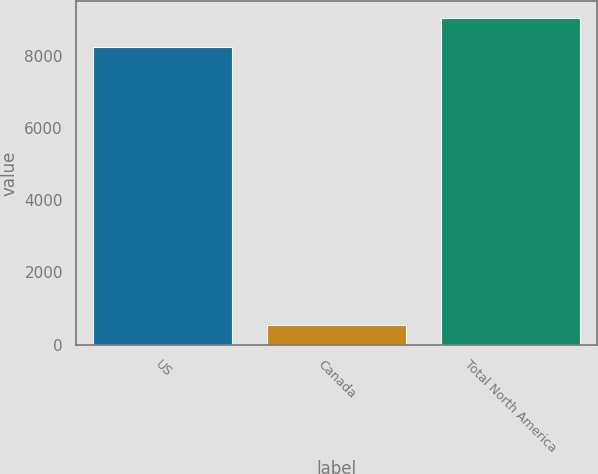<chart> <loc_0><loc_0><loc_500><loc_500><bar_chart><fcel>US<fcel>Canada<fcel>Total North America<nl><fcel>8235<fcel>544<fcel>9058.5<nl></chart> 